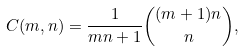Convert formula to latex. <formula><loc_0><loc_0><loc_500><loc_500>C ( m , n ) = \frac { 1 } { m n + 1 } \binom { ( m + 1 ) n } { n } ,</formula> 